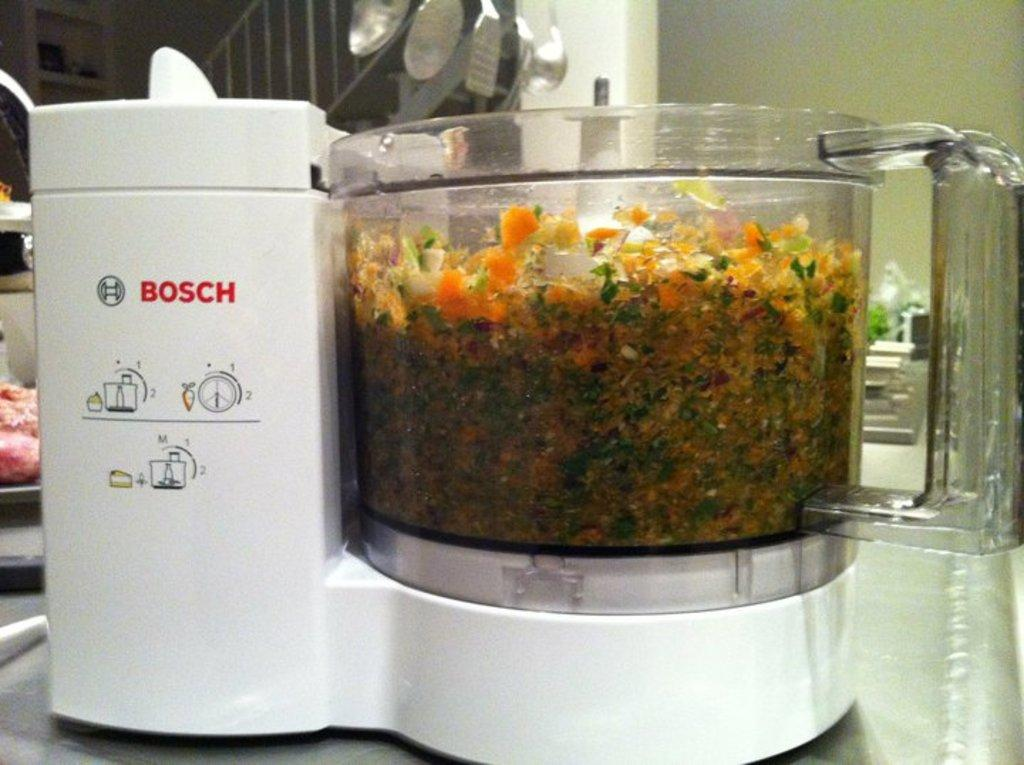Provide a one-sentence caption for the provided image. A large kitchen mixer full of vegetables showing steps 1 + 2 on the side. 